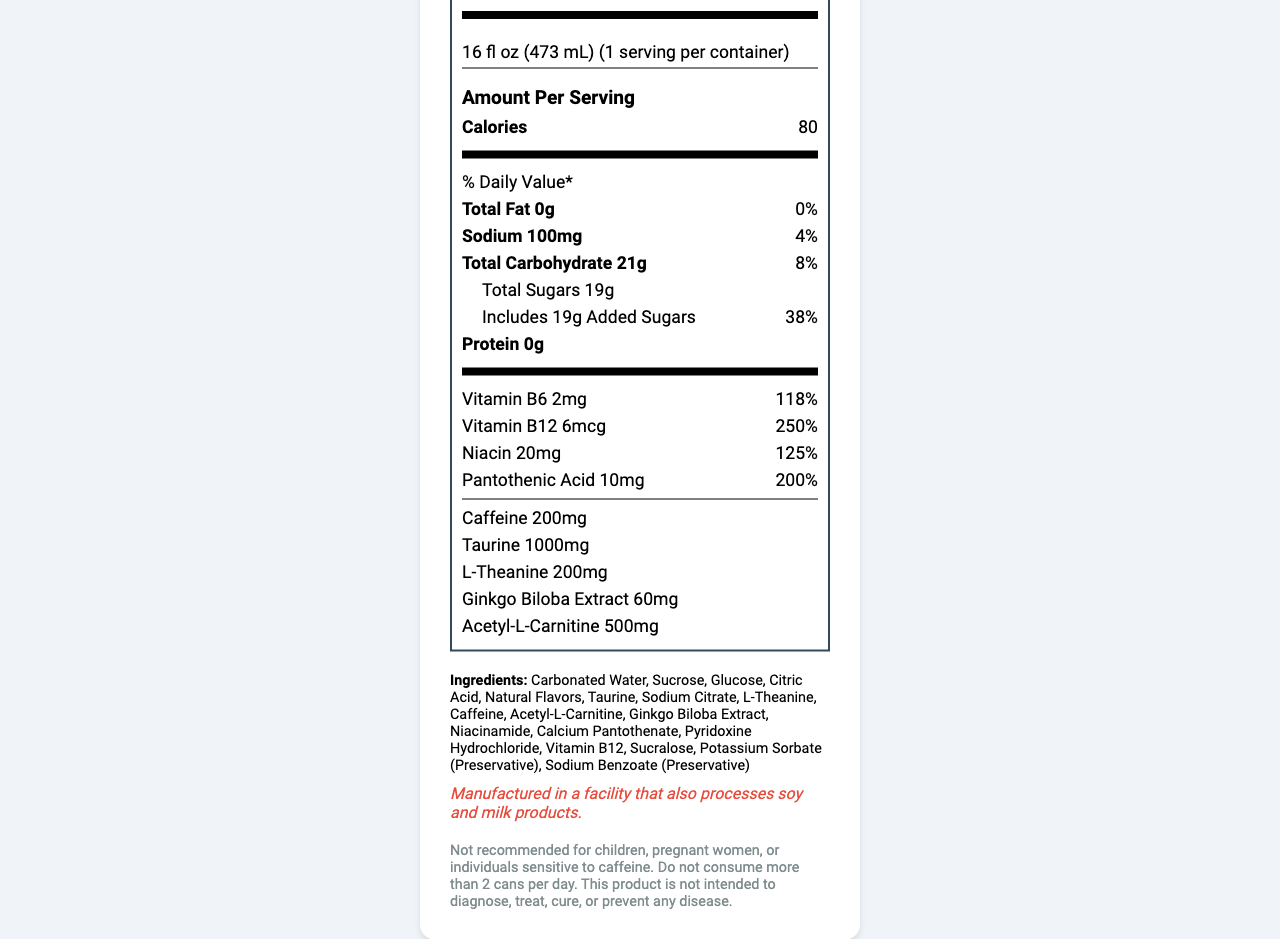what is the serving size? The serving size is mentioned directly in the document as "16 fl oz (473 mL)".
Answer: 16 fl oz (473 mL) how many servings are there per container? The document states that there is 1 serving per container.
Answer: 1 what is the total amount of calories per serving? The amount of calories per serving is given as 80 calories in the document.
Answer: 80 calories how much sodium is there per serving? According to the document, there are 100mg of sodium per serving.
Answer: 100mg what percentage of the daily value of vitamin B12 does one serving contain? The document states that one serving contains 250% of the daily value of vitamin B12.
Answer: 250% how much total carbohydrate is in one serving? The document lists the total carbohydrate content per serving as 21g.
Answer: 21g how many grams of total sugars are in one serving? The total sugars per serving are listed as 19g in the document.
Answer: 19g what is the daily value percentage of added sugars per serving? The document states that the added sugars represent 38% of the daily value.
Answer: 38% how many mg of caffeine does one serving contain? The caffeine content per serving is listed as 200mg in the document.
Answer: 200mg what are the main nutrients listed under the % Daily Value section? A. Sodium B. Total Fat C. Total Carbohydrate D. All of the above The document lists Sodium, Total Fat, and Total Carbohydrate under the % Daily Value section.
Answer: D. All of the above which ingredient is included as a preservative? A. Taurine B. Glucose C. Potassium Sorbate Potassium Sorbate is listed as a preservative in the document.
Answer: C. Potassium Sorbate does this product contain protein? The document shows that the product contains 0g of protein.
Answer: No is this product recommended for children? The disclaimer states that the product is not recommended for children.
Answer: No summarize the main idea of the document. This includes information on serving size, calorie content, various nutrients and their daily values, ingredients, allergen information, and a disclaimer about usage.
Answer: The document provides the nutrition facts and ingredients for BrainBoost Anatomy Focus, an energy drink designed to support extended periods of focused anatomical learning. what is the manufacturing facility's policy regarding allergens? The document includes an allergen information section stating that the product is manufactured in a facility that processes soy and milk products.
Answer: Manufactured in a facility that also processes soy and milk products. what is the source of the document? The document doesn’t provide any information regarding its source.
Answer: Cannot be determined how much taurine is included in one serving? The document states that each serving contains 1000mg of taurine.
Answer: 1000mg 